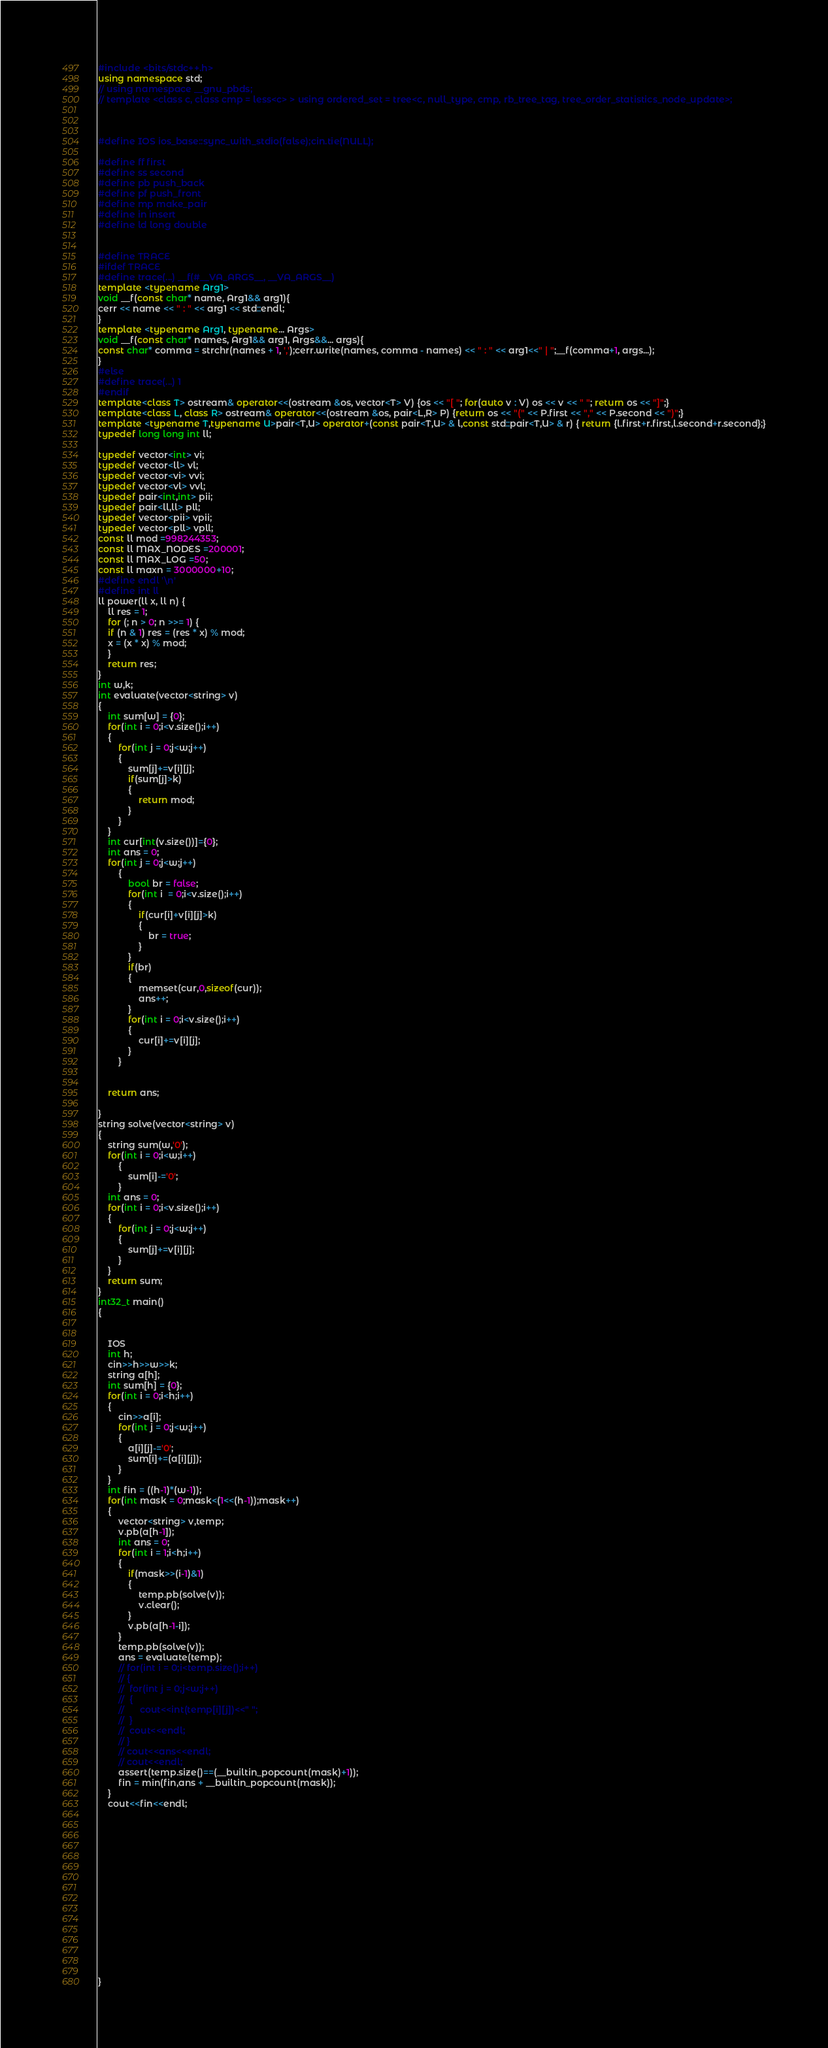Convert code to text. <code><loc_0><loc_0><loc_500><loc_500><_C++_>#include <bits/stdc++.h>
using namespace std;
// using namespace __gnu_pbds;
// template <class c, class cmp = less<c> > using ordered_set = tree<c, null_type, cmp, rb_tree_tag, tree_order_statistics_node_update>;



#define IOS ios_base::sync_with_stdio(false);cin.tie(NULL); 

#define ff first
#define ss second
#define pb push_back
#define pf push_front
#define mp make_pair
#define in insert
#define ld long double


#define TRACE
#ifdef TRACE
#define trace(...) __f(#__VA_ARGS__, __VA_ARGS__)
template <typename Arg1>
void __f(const char* name, Arg1&& arg1){
cerr << name << " : " << arg1 << std::endl;
}
template <typename Arg1, typename... Args>
void __f(const char* names, Arg1&& arg1, Args&&... args){
const char* comma = strchr(names + 1, ',');cerr.write(names, comma - names) << " : " << arg1<<" | ";__f(comma+1, args...);
}
#else
#define trace(...) 1
#endif
template<class T> ostream& operator<<(ostream &os, vector<T> V) {os << "[ "; for(auto v : V) os << v << " "; return os << "]";}
template<class L, class R> ostream& operator<<(ostream &os, pair<L,R> P) {return os << "(" << P.first << "," << P.second << ")";}
template <typename T,typename U>pair<T,U> operator+(const pair<T,U> & l,const std::pair<T,U> & r) { return {l.first+r.first,l.second+r.second};}
typedef long long int ll;

typedef vector<int> vi;
typedef vector<ll> vl;
typedef vector<vi> vvi;
typedef vector<vl> vvl;
typedef pair<int,int> pii;
typedef pair<ll,ll> pll;
typedef vector<pii> vpii;
typedef vector<pll> vpll;
const ll mod =998244353;
const ll MAX_NODES =200001;
const ll MAX_LOG =50;
const ll maxn = 3000000+10;
#define endl '\n'
#define int ll
ll power(ll x, ll n) {
	ll res = 1;
	for (; n > 0; n >>= 1) {
	if (n & 1) res = (res * x) % mod;
	x = (x * x) % mod;
	}
	return res;
}
int w,k;
int evaluate(vector<string> v)
{	
	int sum[w] = {0};
	for(int i = 0;i<v.size();i++)
	{
		for(int j = 0;j<w;j++)
		{
			sum[j]+=v[i][j];
			if(sum[j]>k)
			{
				return mod;
			}
		}
	}
	int cur[int(v.size())]={0};
	int ans = 0;
	for(int j = 0;j<w;j++)
		{	
			bool br = false;
			for(int i  = 0;i<v.size();i++)
			{
				if(cur[i]+v[i][j]>k)
				{
					br = true;
				}
			}
			if(br)
			{
				memset(cur,0,sizeof(cur));
				ans++;
			}
			for(int i = 0;i<v.size();i++)
			{
				cur[i]+=v[i][j];
			}
		}

	
	return ans;
	
}
string solve(vector<string> v)
{
	string sum(w,'0');
	for(int i = 0;i<w;i++)
		{
			sum[i]-='0';
		}
	int ans = 0;
	for(int i = 0;i<v.size();i++)
	{
		for(int j = 0;j<w;j++)
		{
			sum[j]+=v[i][j];
		}
	}
	return sum;
}
int32_t main()
{   


    IOS 
	int h;
	cin>>h>>w>>k;
	string a[h];
	int sum[h] = {0};
	for(int i = 0;i<h;i++)
	{
		cin>>a[i];
		for(int j = 0;j<w;j++)
		{
			a[i][j]-='0';
			sum[i]+=(a[i][j]);
		}
	}
	int fin = ((h-1)*(w-1));
	for(int mask = 0;mask<(1<<(h-1));mask++)
	{	
		vector<string> v,temp;
		v.pb(a[h-1]);
		int ans = 0;
		for(int i = 1;i<h;i++)
		{
			if(mask>>(i-1)&1)
			{	
				temp.pb(solve(v));
				v.clear();
			}
			v.pb(a[h-1-i]);
		}
		temp.pb(solve(v));
		ans = evaluate(temp);
		// for(int i = 0;i<temp.size();i++)
		// {
		// 	for(int j = 0;j<w;j++)
		// 	{
		// 		cout<<int(temp[i][j])<<" ";
		// 	}
		// 	cout<<endl;
		// }
		// cout<<ans<<endl;
		// cout<<endl;
		assert(temp.size()==(__builtin_popcount(mask)+1));
		fin = min(fin,ans + __builtin_popcount(mask));
	}
	cout<<fin<<endl;
	
   
		
	  


    
	
    
    
   
     
       
    

 
}




</code> 